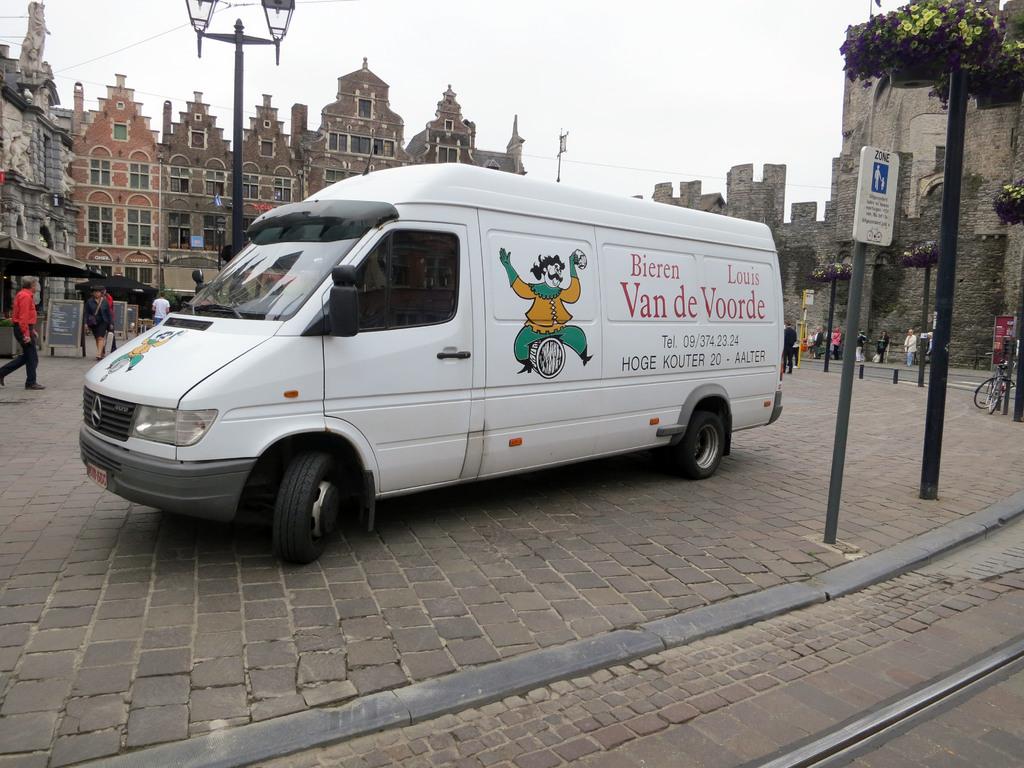What does red letters say?
Your answer should be very brief. Bieren louis van de voorde. 